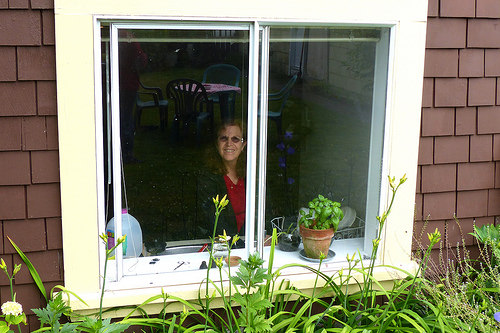<image>
Is there a women behind the window? Yes. From this viewpoint, the women is positioned behind the window, with the window partially or fully occluding the women. 